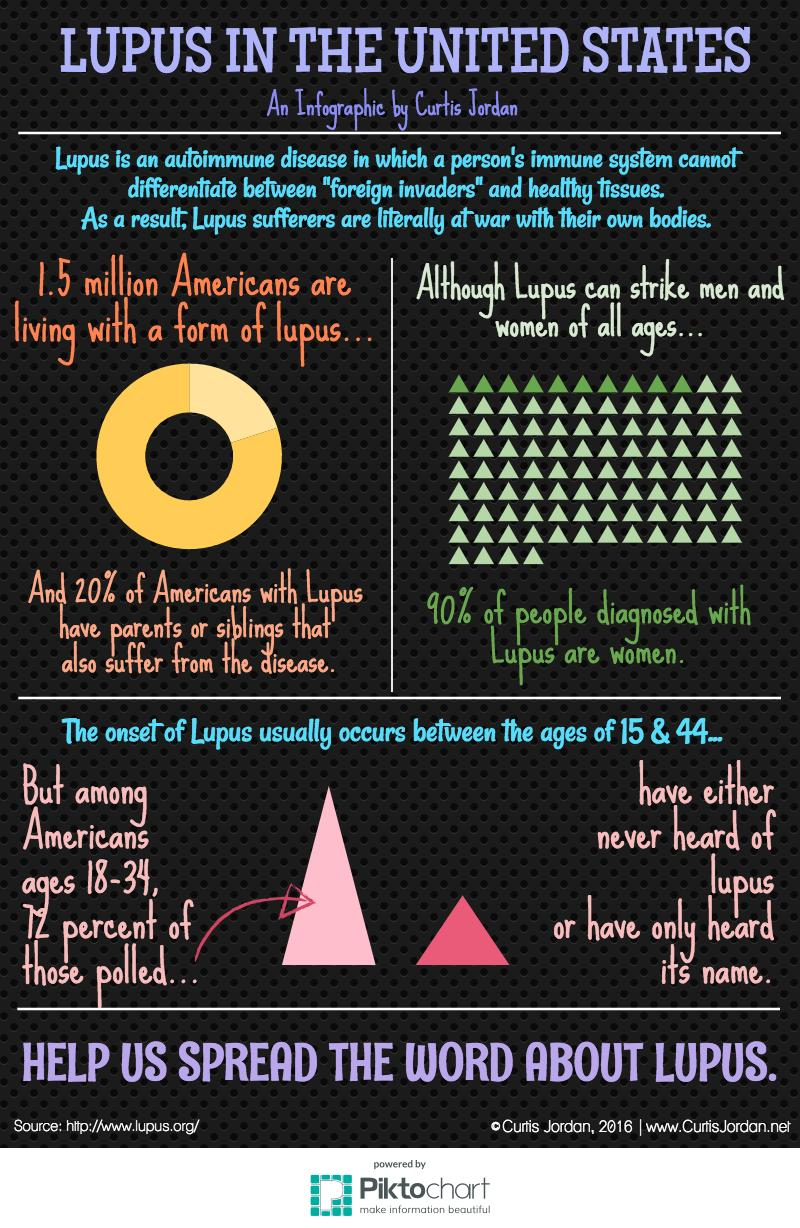Identify some key points in this picture. It is estimated that approximately 1.5 million Americans are affected by lupus, a chronic autoimmune disease that can cause inflammation and damage to various parts of the body. According to data from the United States, approximately 10% of individuals diagnosed with lupus are men. According to recent studies, approximately 20% of Americans with lupus can attribute their condition to genetic inheritance. 